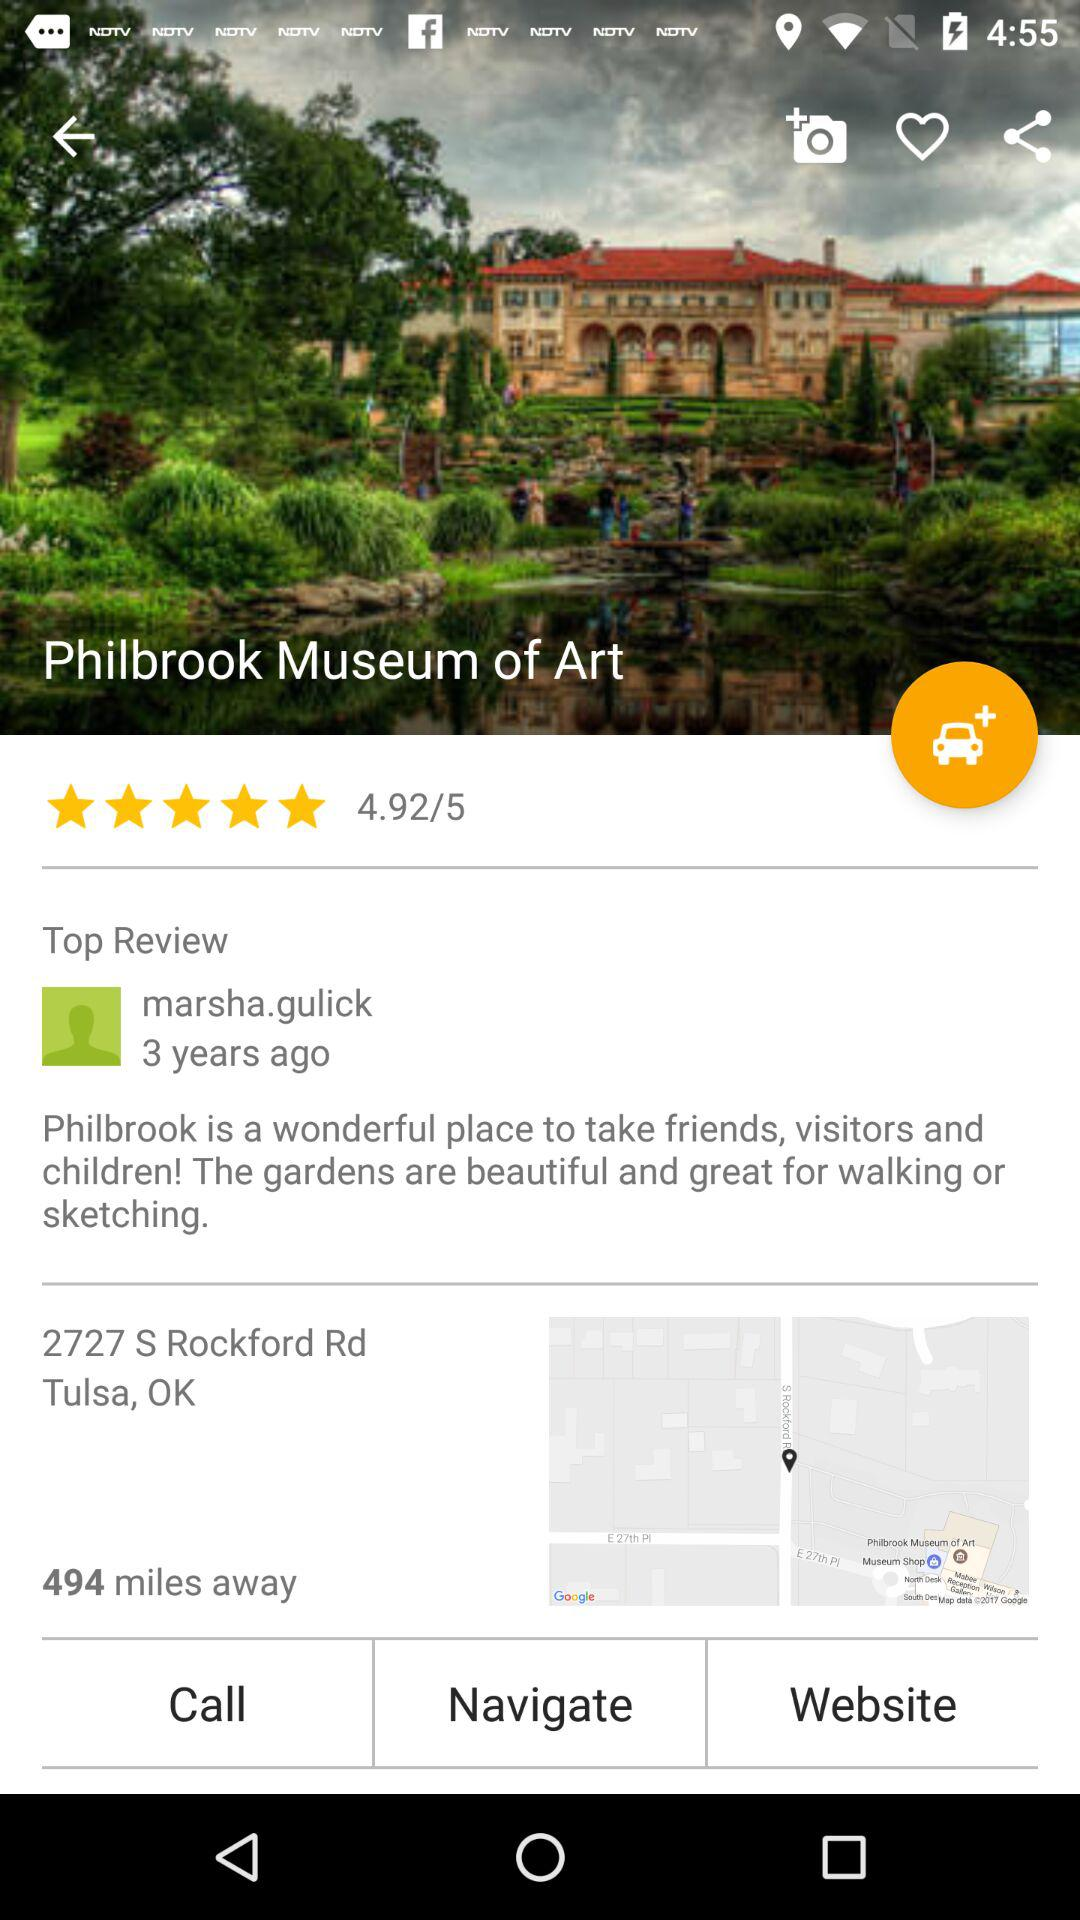What is the rating of the Philbrook Museum of Art? The rating of the Philbrook Museum of Art is 4.92 stars. 